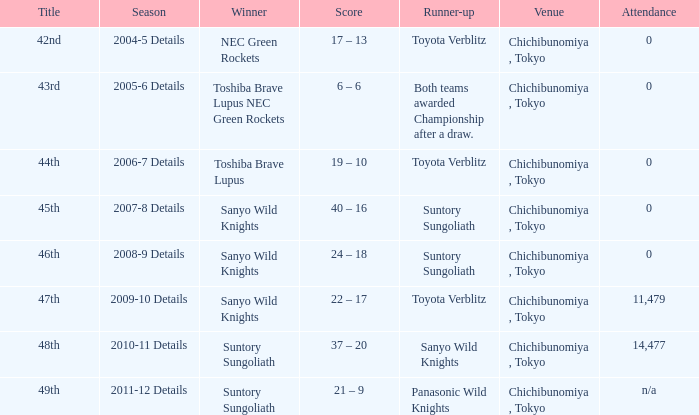What is the Score when the winner was sanyo wild knights, and a Runner-up of suntory sungoliath? 40 – 16, 24 – 18. 